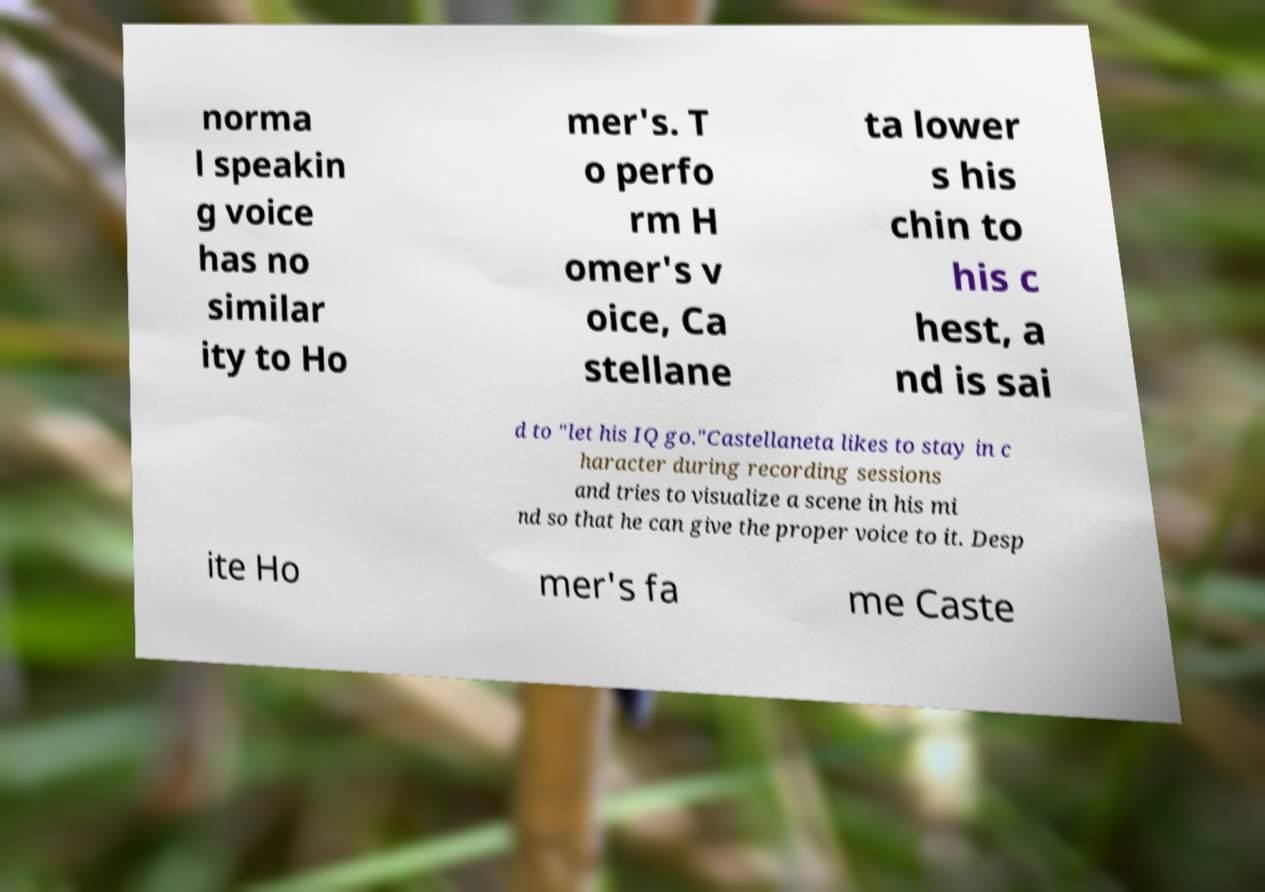For documentation purposes, I need the text within this image transcribed. Could you provide that? norma l speakin g voice has no similar ity to Ho mer's. T o perfo rm H omer's v oice, Ca stellane ta lower s his chin to his c hest, a nd is sai d to "let his IQ go."Castellaneta likes to stay in c haracter during recording sessions and tries to visualize a scene in his mi nd so that he can give the proper voice to it. Desp ite Ho mer's fa me Caste 